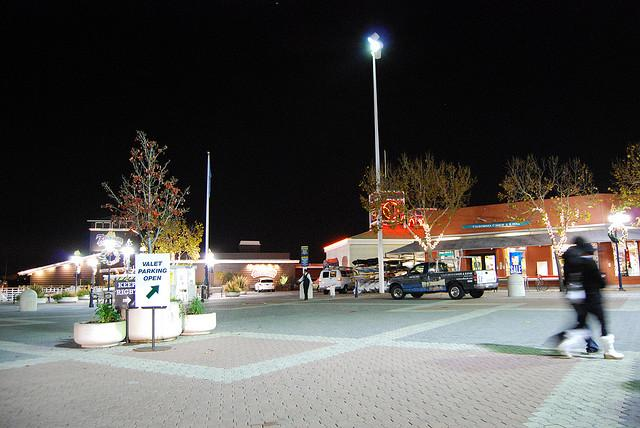What fast food restaurant is seen in the background? mcdonald's 